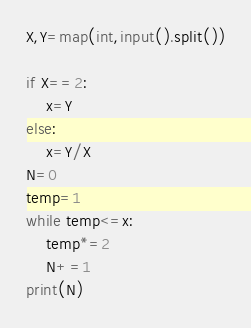Convert code to text. <code><loc_0><loc_0><loc_500><loc_500><_Python_>X,Y=map(int,input().split())

if X==2:
    x=Y
else:
    x=Y/X
N=0
temp=1
while temp<=x:
    temp*=2
    N+=1
print(N)</code> 